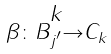Convert formula to latex. <formula><loc_0><loc_0><loc_500><loc_500>\begin{smallmatrix} k \\ \beta \colon B _ { j ^ { \prime } } \to C _ { k } \end{smallmatrix}</formula> 